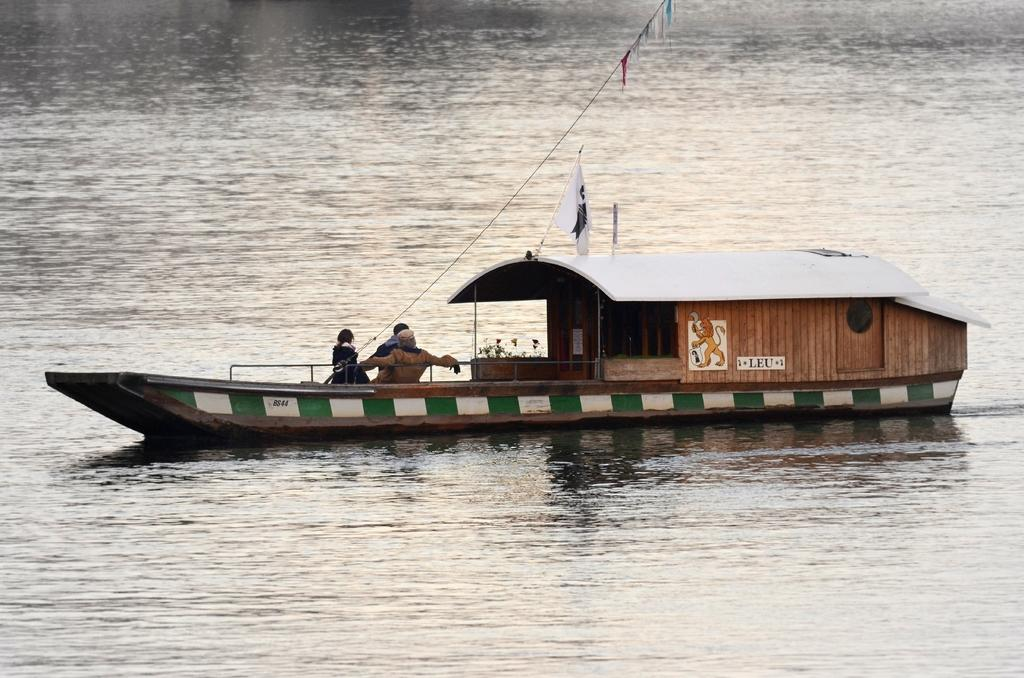What can be seen in the image? There are boats in the image. Where are the boats located? The boats are on a river. Are there any people in the boats? Yes, there are people sitting in the boats. Can you see a kite flying near the boats in the image? No, there is no kite visible in the image. 